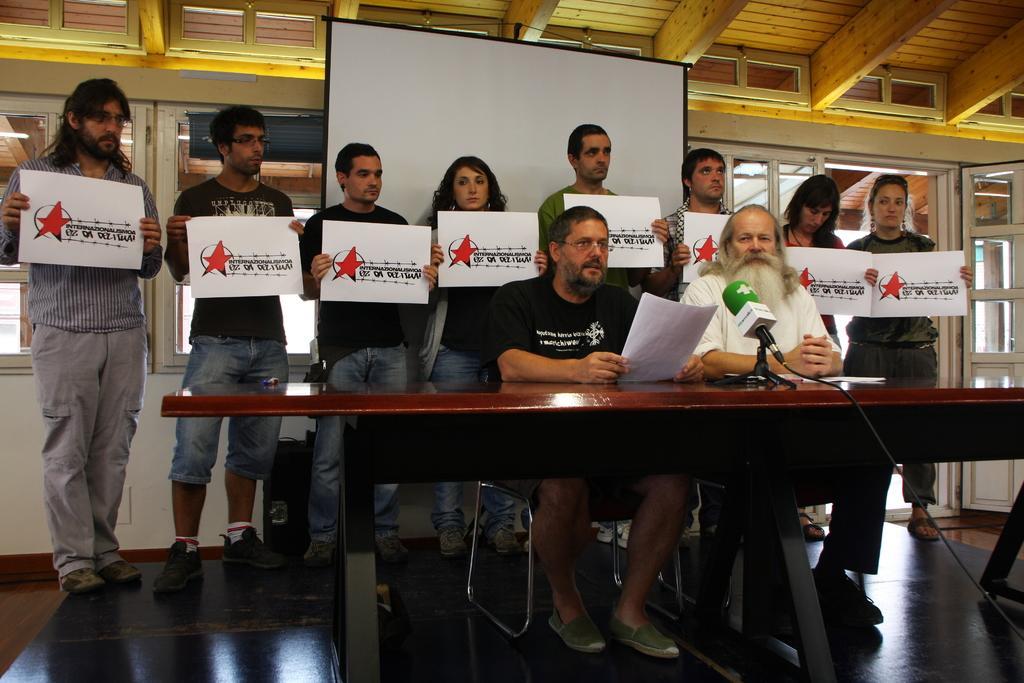Could you give a brief overview of what you see in this image? In this picture, there were group of people on the stage. Two persons were sitting behind a table, one person is wearing black T shirt and green shoes holding a paper and another person is wearing white T shirt, black pant and black shoes. There is a mile between them. All other remaining persons were standing behind them. All the persons are holding papers and some text printed on it. In the background there is a board and windows. 